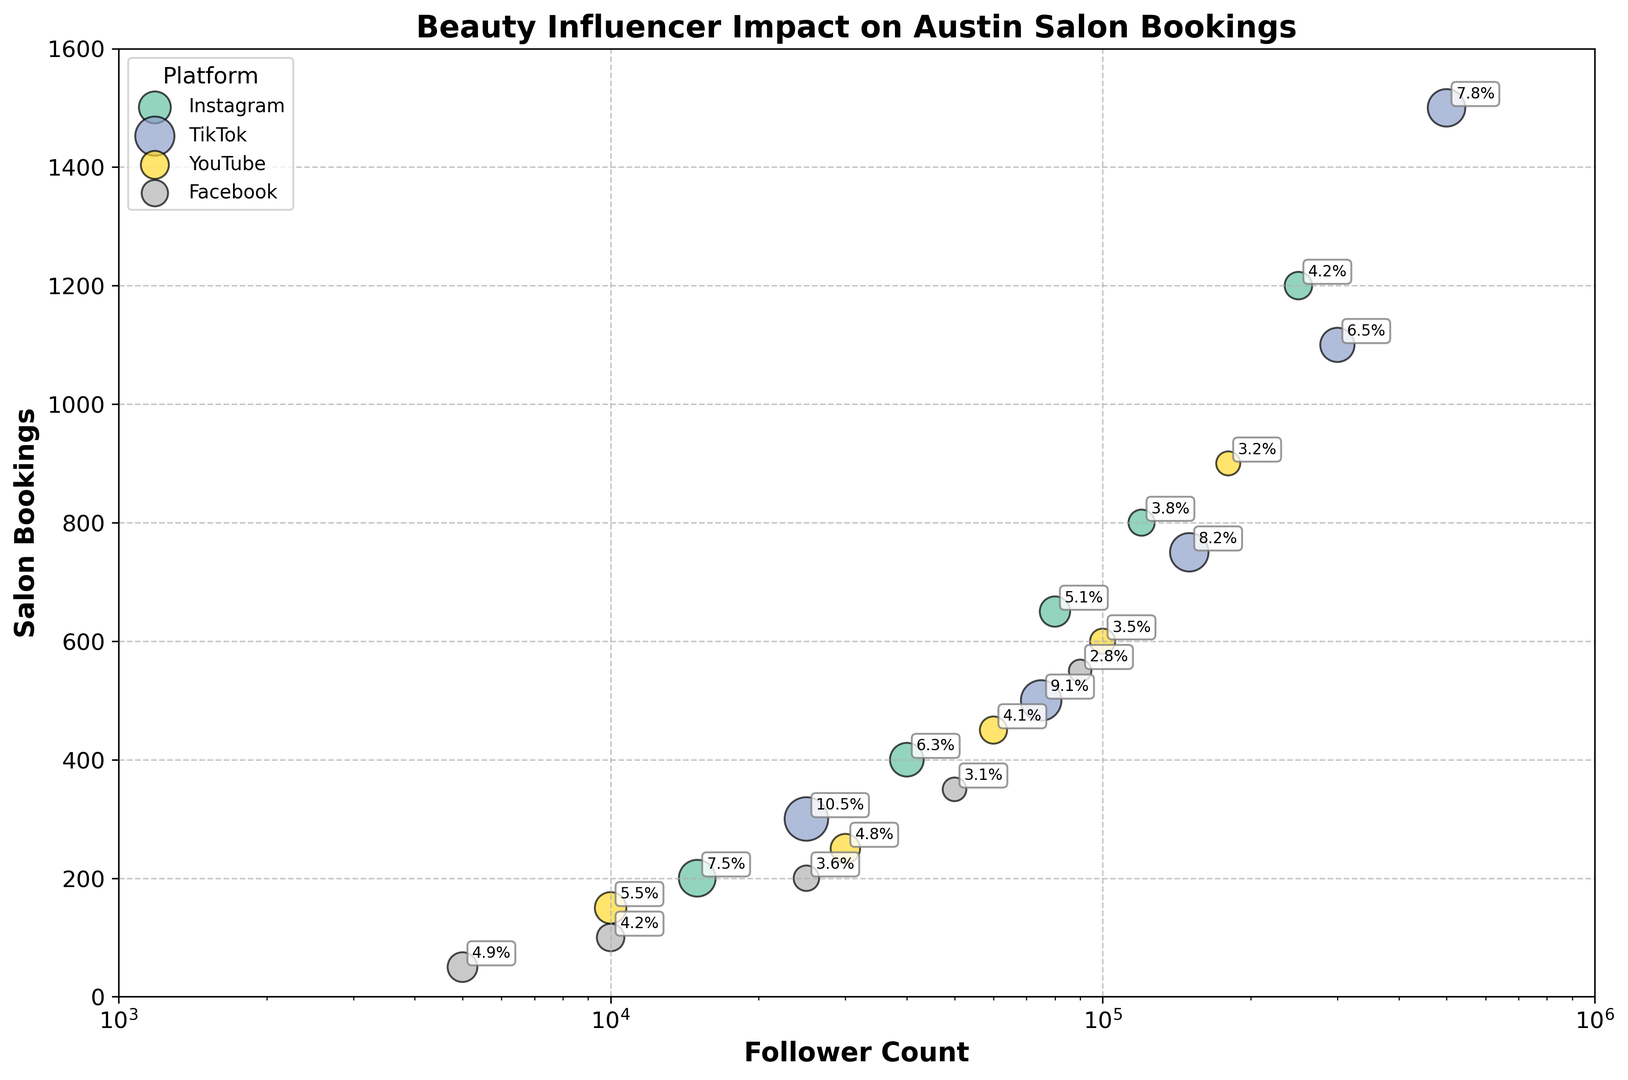What's the platform with the highest engagement rate? To find the platform with the highest engagement rate, look at the labels next to the largest bubbles. TikTok has the highest engagement rate of 10.5% (25,000 followers, 300 salon bookings).
Answer: TikTok Which platform has the most significant influence on salon bookings? Compare the top data points in terms of salon bookings. TikTok (500,000 followers, 7.8% engagement rate) has the highest number with 1500 bookings.
Answer: TikTok How does engagement rate affect salon bookings between two influencers on YouTube? Look for similar follower count and compare engagement rates and salon bookings. One influencer with 100,000 followers and 3.5% engagement rate has 600 bookings, while another with 60,000 followers and 4.1% engagement rate has 450 bookings. The higher engagement rate corresponds to more salon bookings relative to the follower count.
Answer: Higher engagement rate leads to higher bookings relative to follower count Which influencer has the lowest salon bookings? Identify the smallest bubble on the y-axis for all platforms. The influencer with 5,000 followers on Facebook has the lowest salon bookings at 50.
Answer: Facebook (5,000 followers, 50 bookings) What is the average salon bookings for Instagram influencers? Calculate the sum of salon bookings for Instagram influencers (1200 + 800 + 650 + 400 + 200 = 3250) and divide by the number of influencers (5). The average is \( 3250 / 5 = 650 \).
Answer: 650 Between the influencers on TikTok and YouTube, which group has a higher median salon bookings? List the salon bookings for TikTok (1500, 1100, 750, 500, 300) and YouTube (900, 600, 450, 250, 150). Order them and find the middle values (TikTok: 750, YouTube: 450), resulting in a comparison where TikTok has higher median bookings.
Answer: TikTok (750 bookings) Which influencer has the largest bubble on the plot, and what does it signify? Identify the largest bubble visually. It is the TikTok influencer with 150,000 followers and an 8.2% engagement rate, signifying high engagement leading to substantial influence on bookings (750).
Answer: TikTok (150,000 followers, 8.2% engagement rate) How many more salon bookings does an influencer with 500,000 followers on TikTok have compared to an influencer with similar followers on Instagram (250,000)? The influencer with 500,000 followers on TikTok has 1500 bookings, and one with 250,000 followers on Instagram has 1200 bookings. The difference is \( 1500 - 1200 = 300 \).
Answer: 300 more What is the color representing the Facebook influencers? Look at the legend to find the color corresponding to "Facebook."
Answer: Green 